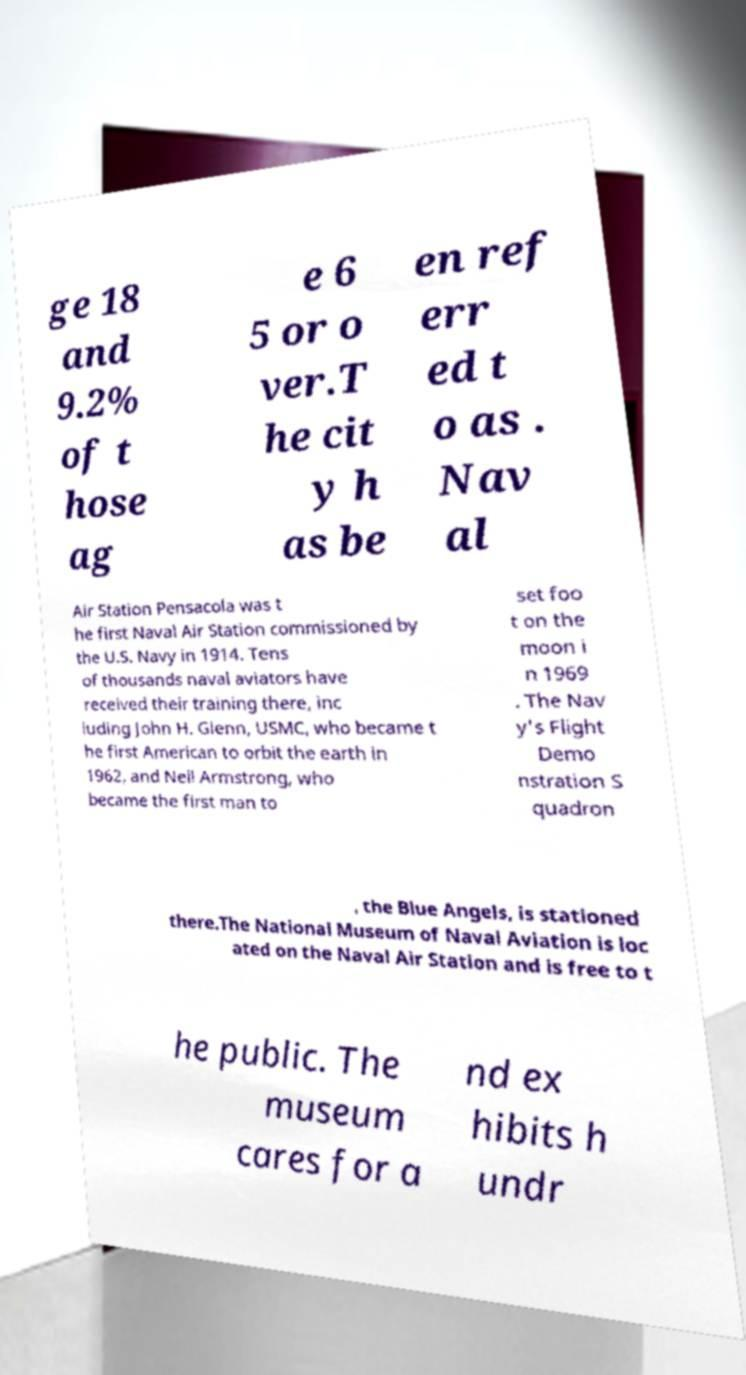Could you extract and type out the text from this image? ge 18 and 9.2% of t hose ag e 6 5 or o ver.T he cit y h as be en ref err ed t o as . Nav al Air Station Pensacola was t he first Naval Air Station commissioned by the U.S. Navy in 1914. Tens of thousands naval aviators have received their training there, inc luding John H. Glenn, USMC, who became t he first American to orbit the earth in 1962, and Neil Armstrong, who became the first man to set foo t on the moon i n 1969 . The Nav y's Flight Demo nstration S quadron , the Blue Angels, is stationed there.The National Museum of Naval Aviation is loc ated on the Naval Air Station and is free to t he public. The museum cares for a nd ex hibits h undr 